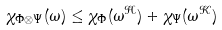<formula> <loc_0><loc_0><loc_500><loc_500>\chi _ { \Phi \otimes \Psi } ( \omega ) \leq \chi _ { \Phi } ( \omega ^ { \mathcal { H } } ) + \chi _ { \Psi } ( \omega ^ { \mathcal { K } } )</formula> 